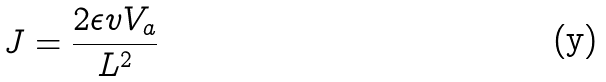Convert formula to latex. <formula><loc_0><loc_0><loc_500><loc_500>J = \frac { 2 \epsilon v V _ { a } } { L ^ { 2 } }</formula> 